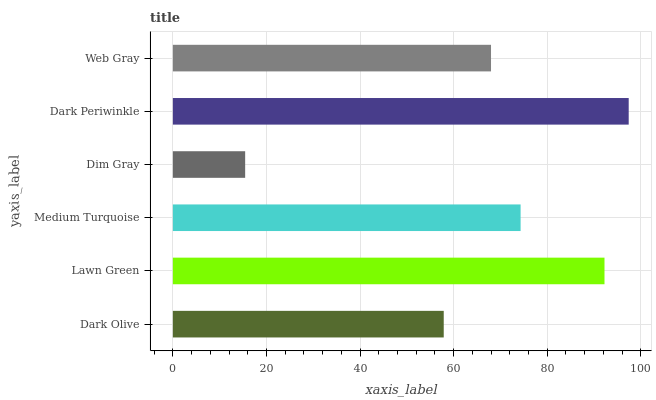Is Dim Gray the minimum?
Answer yes or no. Yes. Is Dark Periwinkle the maximum?
Answer yes or no. Yes. Is Lawn Green the minimum?
Answer yes or no. No. Is Lawn Green the maximum?
Answer yes or no. No. Is Lawn Green greater than Dark Olive?
Answer yes or no. Yes. Is Dark Olive less than Lawn Green?
Answer yes or no. Yes. Is Dark Olive greater than Lawn Green?
Answer yes or no. No. Is Lawn Green less than Dark Olive?
Answer yes or no. No. Is Medium Turquoise the high median?
Answer yes or no. Yes. Is Web Gray the low median?
Answer yes or no. Yes. Is Dark Olive the high median?
Answer yes or no. No. Is Dark Olive the low median?
Answer yes or no. No. 